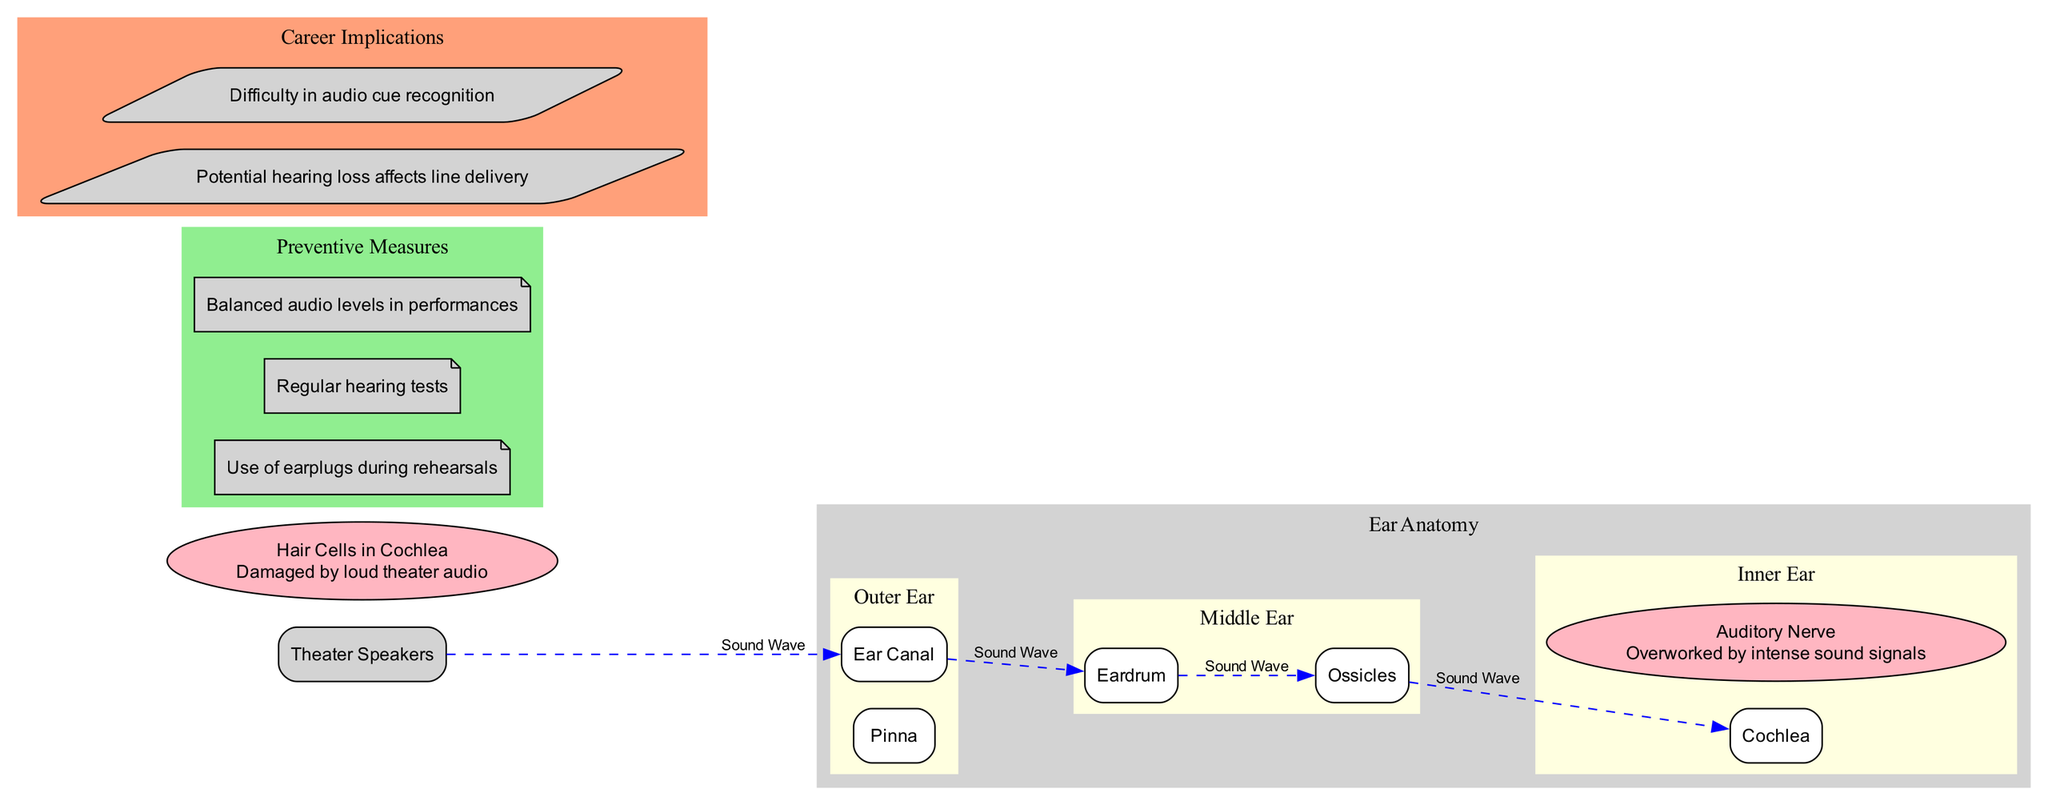What's the name of the first structure in the outer ear? The first structure listed in the outer ear is the "Pinna", which is mentioned under the main structures section.
Answer: Pinna How many parts are there in the middle ear? The middle ear includes two parts: the "Eardrum" and "Ossicles." Counting these gives a total of two parts.
Answer: 2 What area is damaged by loud theater audio? The diagram specifies that "Hair Cells in Cochlea" are damaged by loud theater audio, making this the answer to the question.
Answer: Hair Cells in Cochlea What is the last part in the sound wave path? The sound wave path concludes with the "Cochlea" as it is the last element shown in the sequential flow of the diagram.
Answer: Cochlea Which preventive measure involves the use of personal equipment? The preventive measure involving personal equipment is "Use of earplugs during rehearsals" as it suggests a personal protective approach to managing sound exposure.
Answer: Use of earplugs during rehearsals What is the relationship between the auditory nerve and loud sounds? The diagram describes that the "Auditory Nerve" is "Overworked by intense sound signals," indicating a stressed relationship due to exposure to loud sounds.
Answer: Overworked by intense sound signals How many preventive measures are mentioned in the diagram? The diagram lists three preventive measures: "Use of earplugs during rehearsals," "Regular hearing tests," and "Balanced audio levels in performances." Counting these gives a total of three measures.
Answer: 3 What are two potential career implications for theater students regarding their hearing? The two specified career implications are "Potential hearing loss affects line delivery" and "Difficulty in audio cue recognition," both essential for theater performance.
Answer: Potential hearing loss affects line delivery and Difficulty in audio cue recognition 